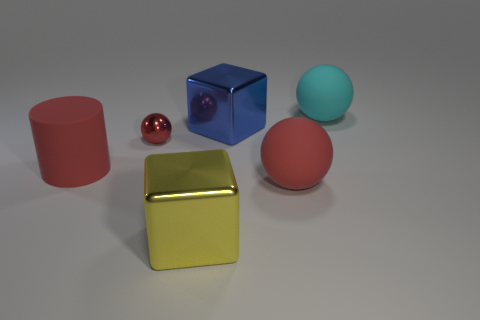Can you describe the lighting in the scene and how it affects the appearance of the objects? The scene is lit in a way that produces soft shadows and subtle highlights on the objects, suggesting a diffused light source, perhaps from above. The lighting accentuates the reflective properties of the metallic yellow cube and the small red sphere, creating bright spots that indicate a high level of glossiness. The blue cube and red cylinder are lit in such a way that their colors appear vibrant, and their shadows give a sense of their position in space. The pink sphere, with its matte surface, absorbs more light, resulting in less pronounced highlights and giving it a softer appearance. The overall lighting contributes to the depth and realism of the scene, allowing each object's texture to be distinctly observed. 